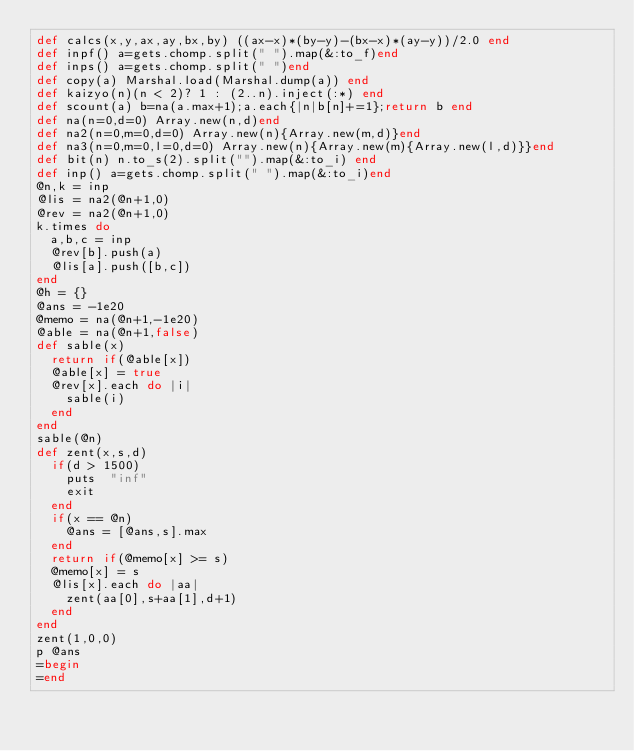Convert code to text. <code><loc_0><loc_0><loc_500><loc_500><_Ruby_>def calcs(x,y,ax,ay,bx,by) ((ax-x)*(by-y)-(bx-x)*(ay-y))/2.0 end
def inpf() a=gets.chomp.split(" ").map(&:to_f)end
def inps() a=gets.chomp.split(" ")end  
def copy(a) Marshal.load(Marshal.dump(a)) end
def kaizyo(n)(n < 2)? 1 : (2..n).inject(:*) end
def scount(a) b=na(a.max+1);a.each{|n|b[n]+=1};return b end
def na(n=0,d=0) Array.new(n,d)end
def na2(n=0,m=0,d=0) Array.new(n){Array.new(m,d)}end
def na3(n=0,m=0,l=0,d=0) Array.new(n){Array.new(m){Array.new(l,d)}}end
def bit(n) n.to_s(2).split("").map(&:to_i) end
def inp() a=gets.chomp.split(" ").map(&:to_i)end
@n,k = inp
@lis = na2(@n+1,0)
@rev = na2(@n+1,0)
k.times do
  a,b,c = inp
  @rev[b].push(a)
  @lis[a].push([b,c])
end
@h = {}
@ans = -1e20
@memo = na(@n+1,-1e20)
@able = na(@n+1,false)
def sable(x)
  return if(@able[x])
  @able[x] = true
  @rev[x].each do |i|
    sable(i)
  end
end
sable(@n)
def zent(x,s,d)
  if(d > 1500)
    puts  "inf"
    exit
  end
  if(x == @n)
    @ans = [@ans,s].max
  end
  return if(@memo[x] >= s)
  @memo[x] = s
  @lis[x].each do |aa|
    zent(aa[0],s+aa[1],d+1)
  end
end
zent(1,0,0)
p @ans
=begin
=end
</code> 